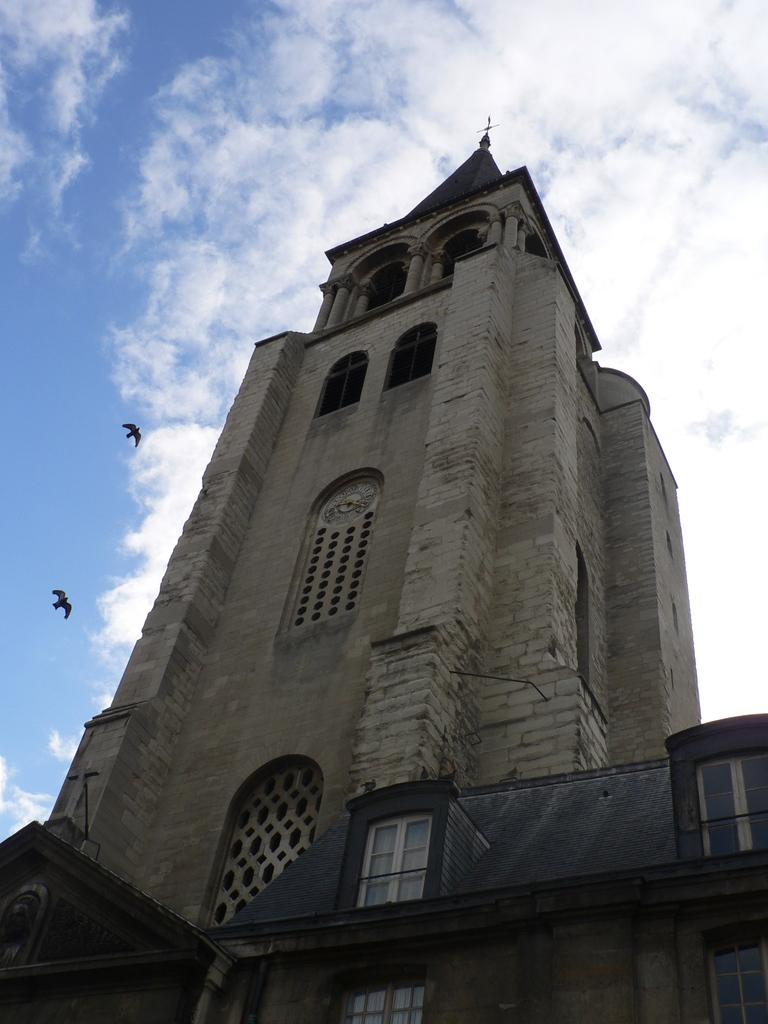What structure is depicted in the image? There is a building in the image. What else can be seen in the image besides the building? There are birds flying in the image. What is visible in the background of the image? The sky is visible in the background of the image. What can be observed in the sky? Clouds are present in the sky. What type of knowledge is being shared during the meeting in the image? There is no meeting present in the image, so it is not possible to determine what type of knowledge might be shared. 